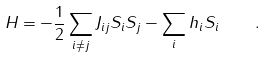<formula> <loc_0><loc_0><loc_500><loc_500>H = - \frac { 1 } { 2 } \sum _ { i \neq j } J _ { i j } S _ { i } S _ { j } - \sum _ { i } h _ { i } S _ { i } \quad .</formula> 